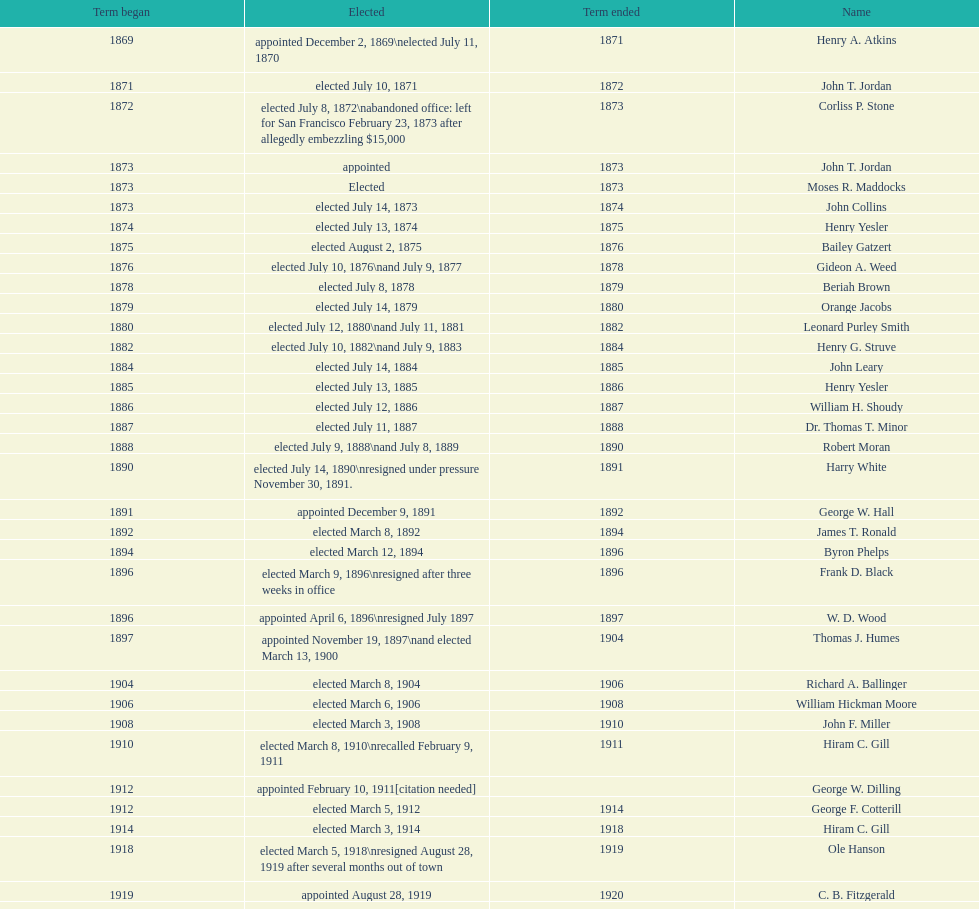Which mayor seattle, washington resigned after only three weeks in office in 1896? Frank D. Black. 